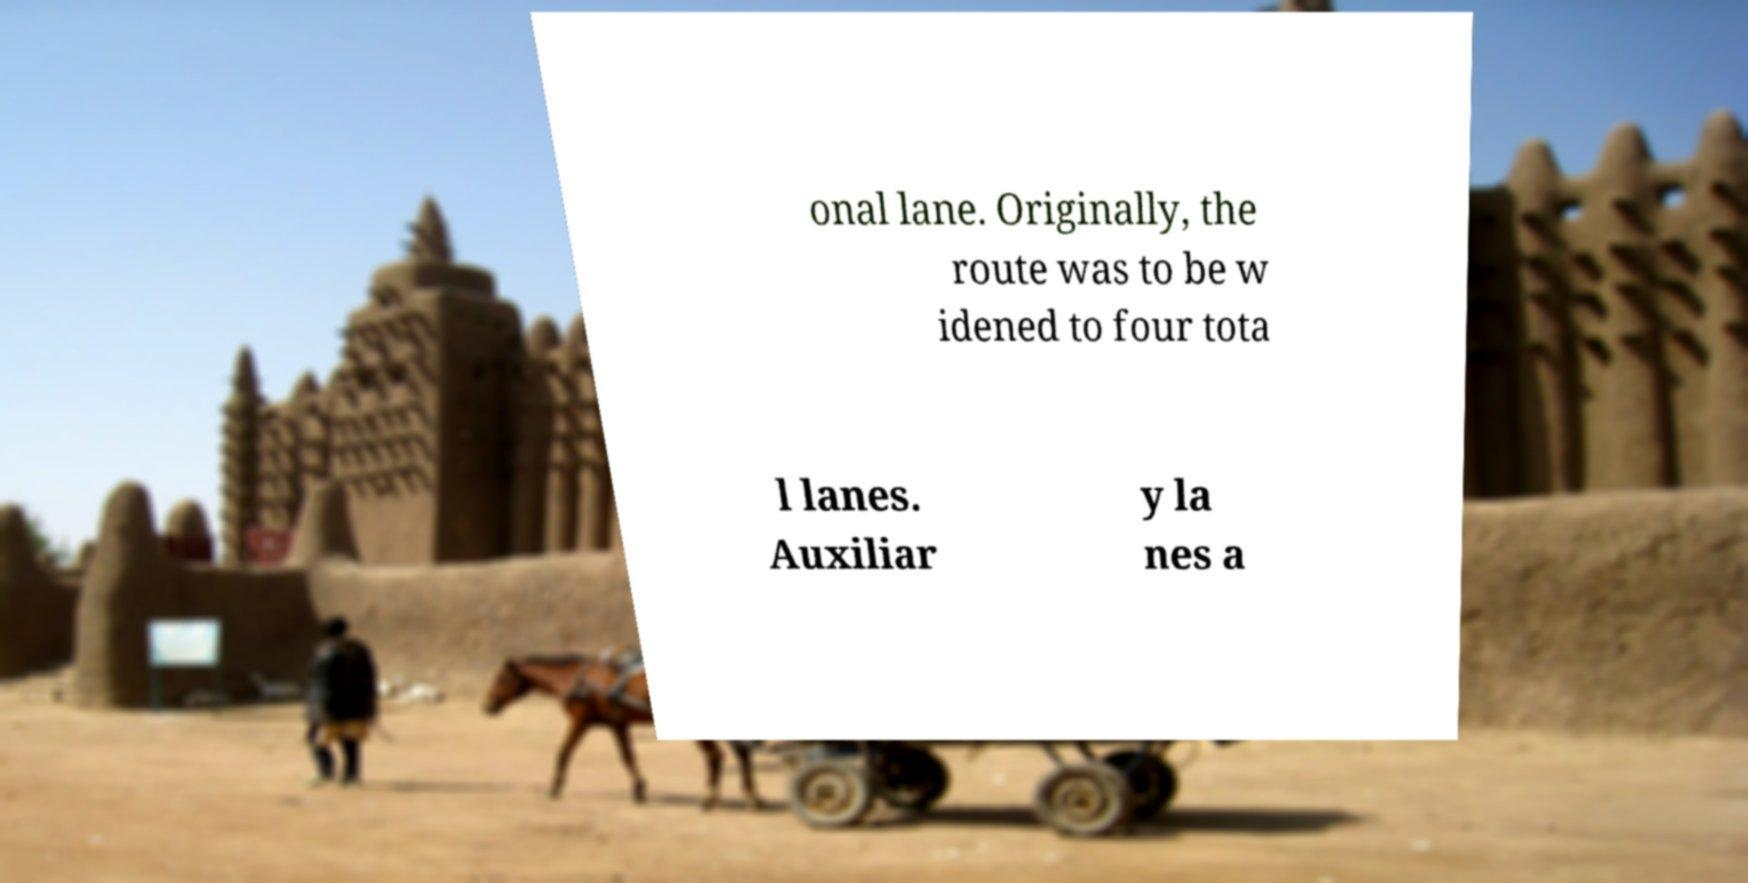Please read and relay the text visible in this image. What does it say? onal lane. Originally, the route was to be w idened to four tota l lanes. Auxiliar y la nes a 